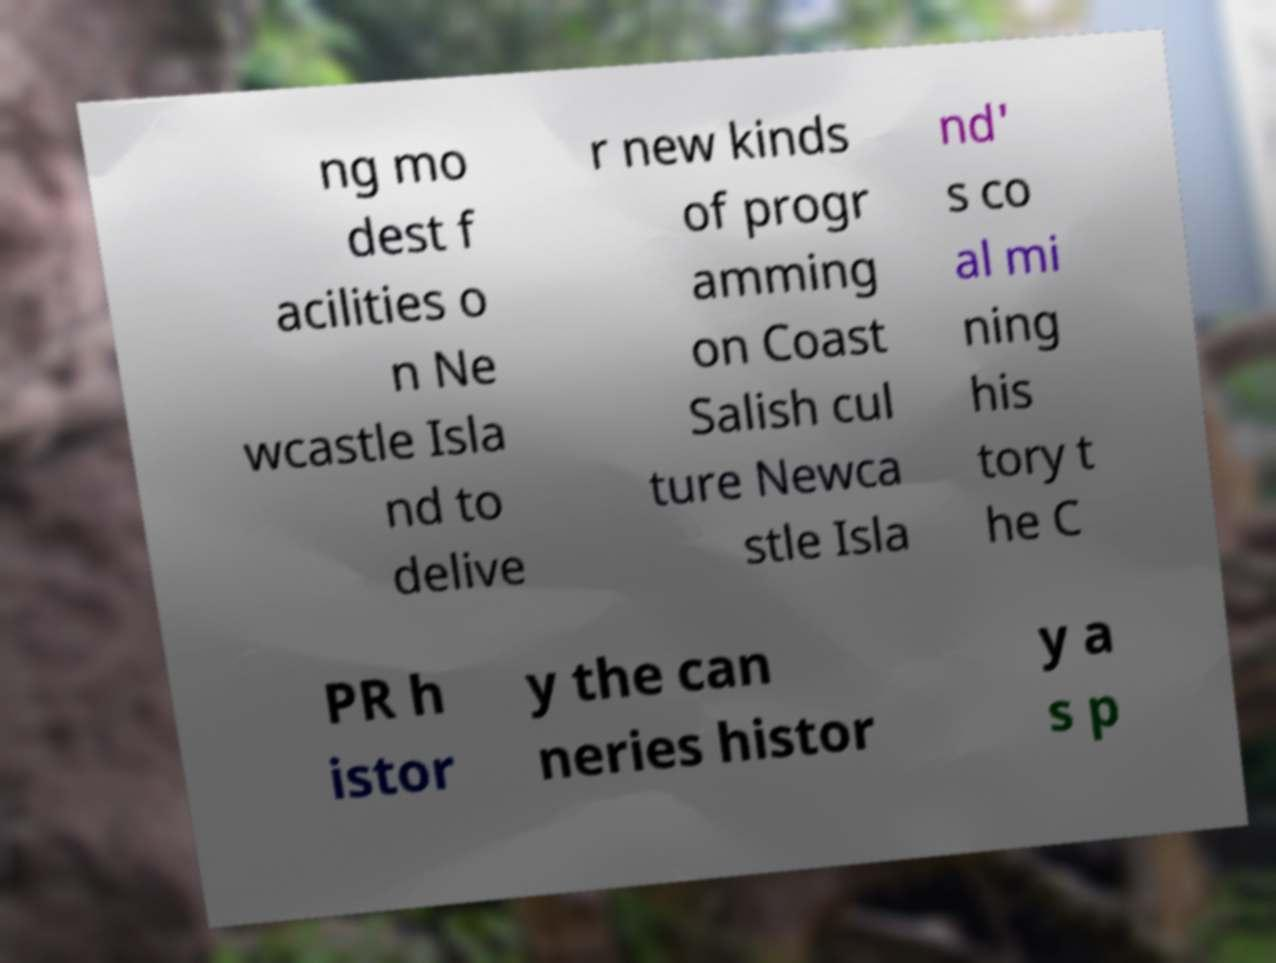Can you accurately transcribe the text from the provided image for me? ng mo dest f acilities o n Ne wcastle Isla nd to delive r new kinds of progr amming on Coast Salish cul ture Newca stle Isla nd' s co al mi ning his tory t he C PR h istor y the can neries histor y a s p 